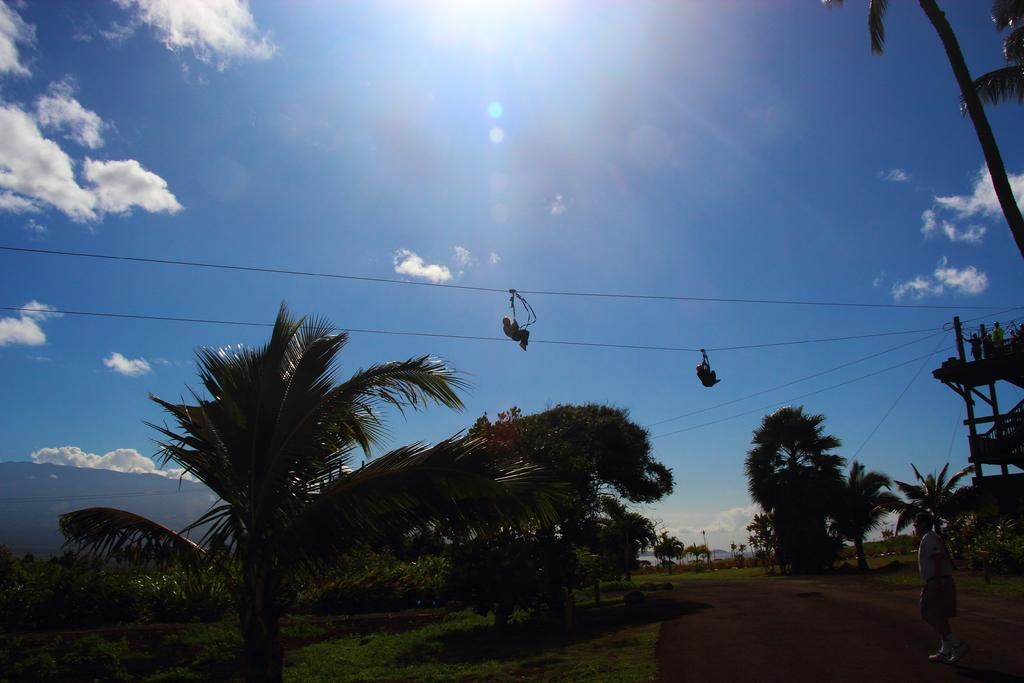How many people are in the ropeway in the image? There are two people in the ropeway in the image. What type of vegetation can be seen in the image? There are trees and plants in the image. What is visible in the sky in the image? Clouds are visible in the sky in the image. What type of record is being played in the image? There is no record present in the image; it features two people in a ropeway and trees, plants, and clouds. What type of act is being performed by the trees in the image? There is no act being performed by the trees in the image; they are simply part of the natural landscape. 